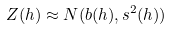<formula> <loc_0><loc_0><loc_500><loc_500>Z ( h ) \approx N ( b ( h ) , s ^ { 2 } ( h ) )</formula> 